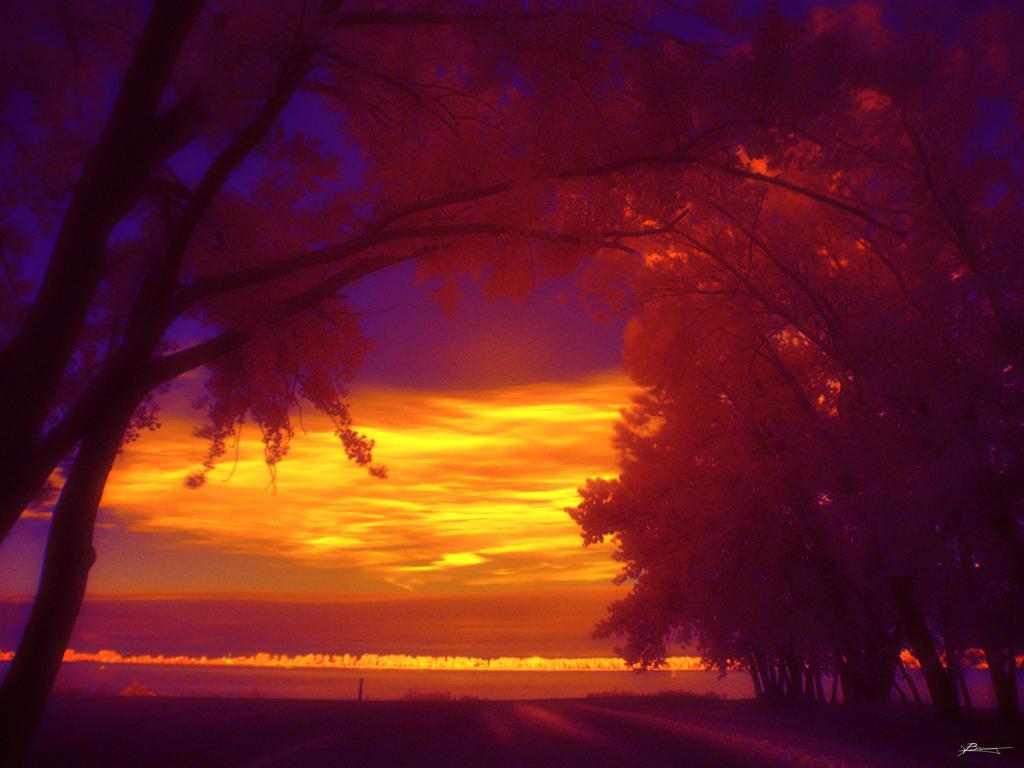Can you describe this image briefly? In this image we can see few trees and the sky in the background. 